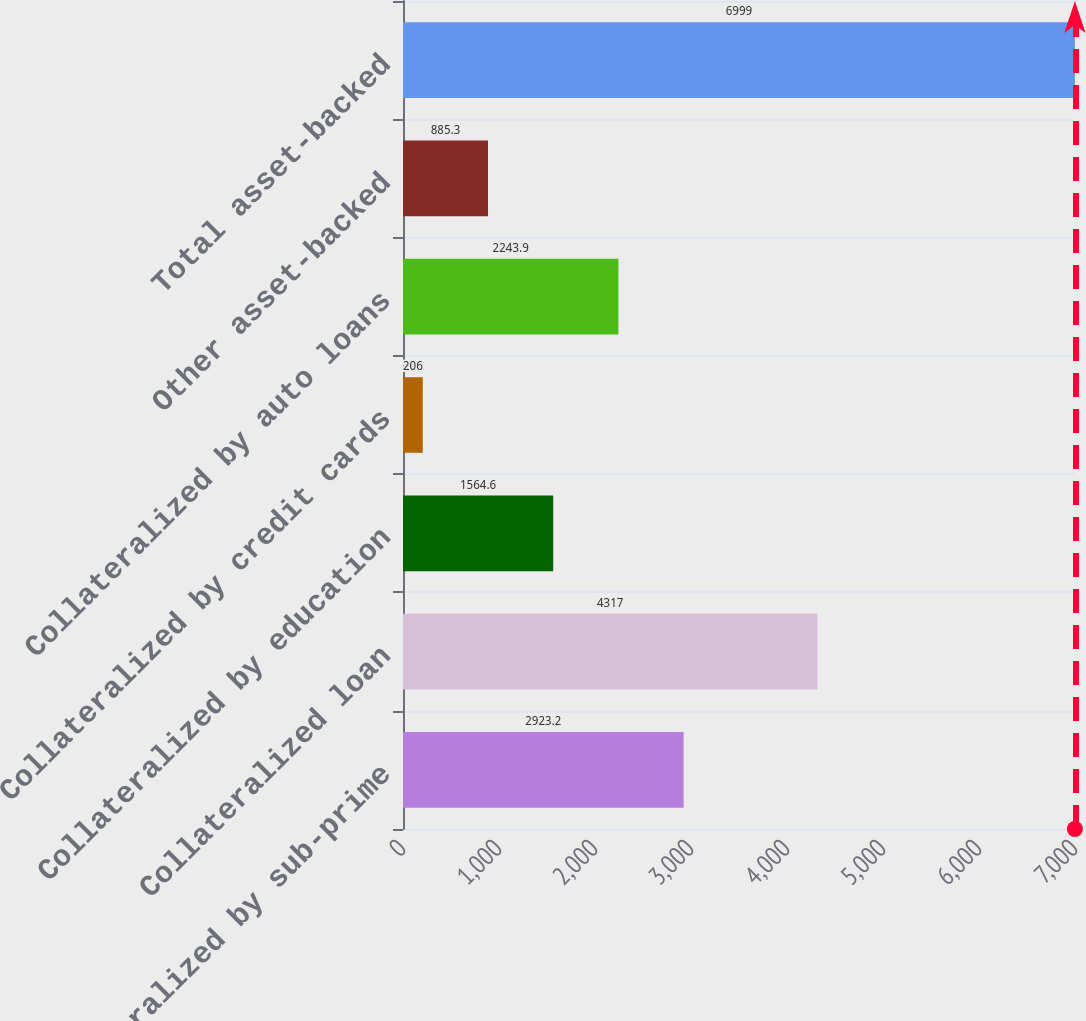<chart> <loc_0><loc_0><loc_500><loc_500><bar_chart><fcel>Collateralized by sub-prime<fcel>Collateralized loan<fcel>Collateralized by education<fcel>Collateralized by credit cards<fcel>Collateralized by auto loans<fcel>Other asset-backed<fcel>Total asset-backed<nl><fcel>2923.2<fcel>4317<fcel>1564.6<fcel>206<fcel>2243.9<fcel>885.3<fcel>6999<nl></chart> 